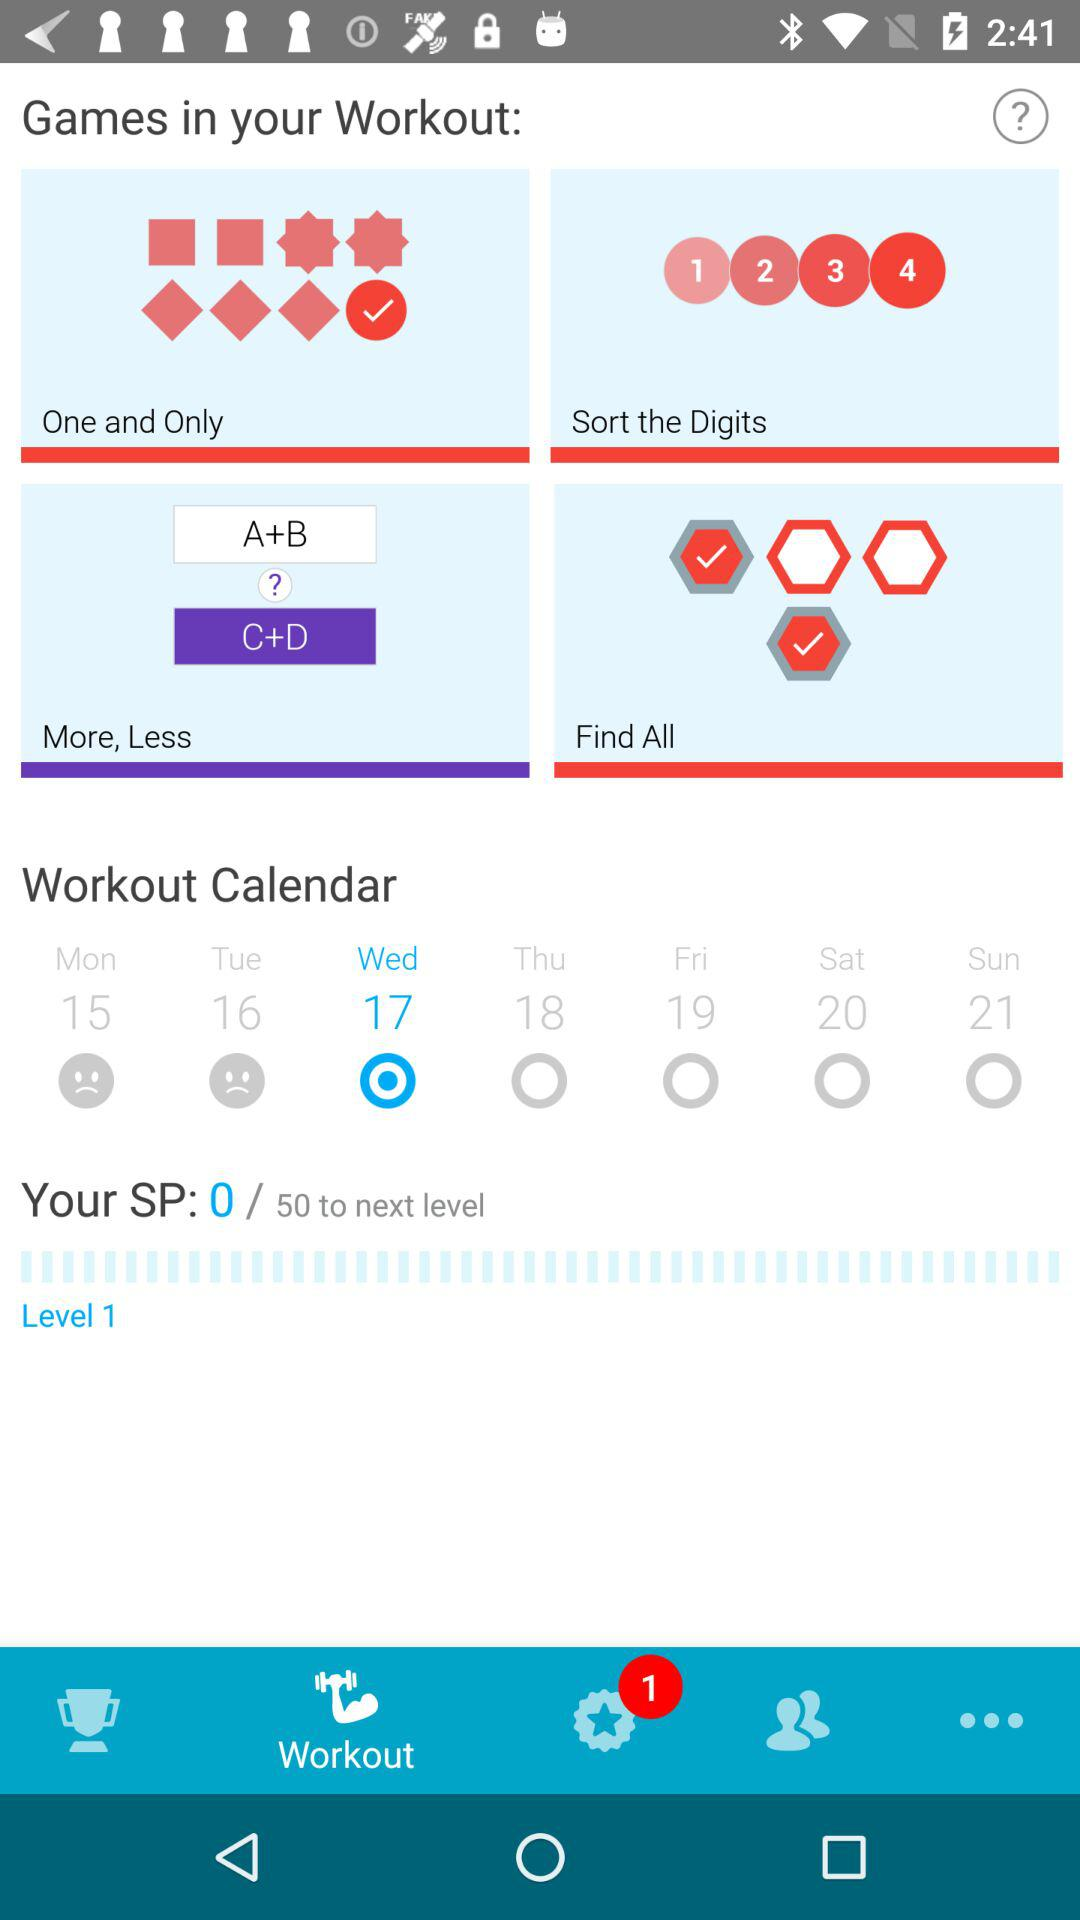Which day is selected for the workout? The selected day for the workout is Wednesday. 